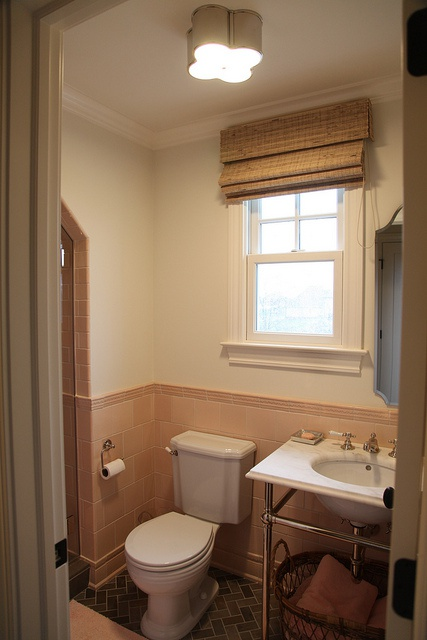Describe the objects in this image and their specific colors. I can see toilet in black, brown, gray, maroon, and tan tones and sink in black, tan, and lightgray tones in this image. 